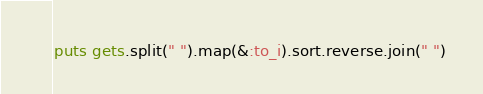<code> <loc_0><loc_0><loc_500><loc_500><_Ruby_>puts gets.split(" ").map(&:to_i).sort.reverse.join(" ")</code> 